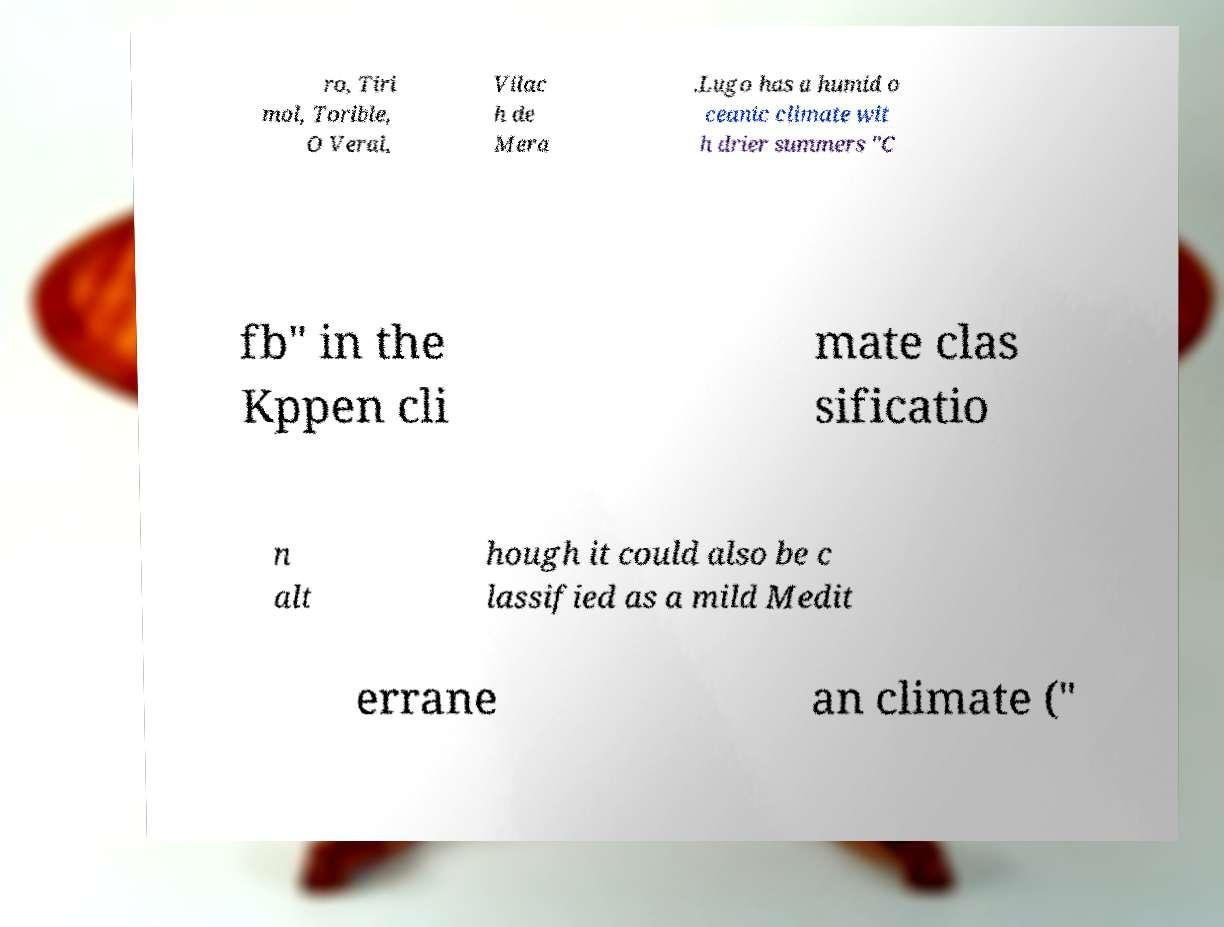For documentation purposes, I need the text within this image transcribed. Could you provide that? ro, Tiri mol, Torible, O Veral, Vilac h de Mera .Lugo has a humid o ceanic climate wit h drier summers "C fb" in the Kppen cli mate clas sificatio n alt hough it could also be c lassified as a mild Medit errane an climate (" 